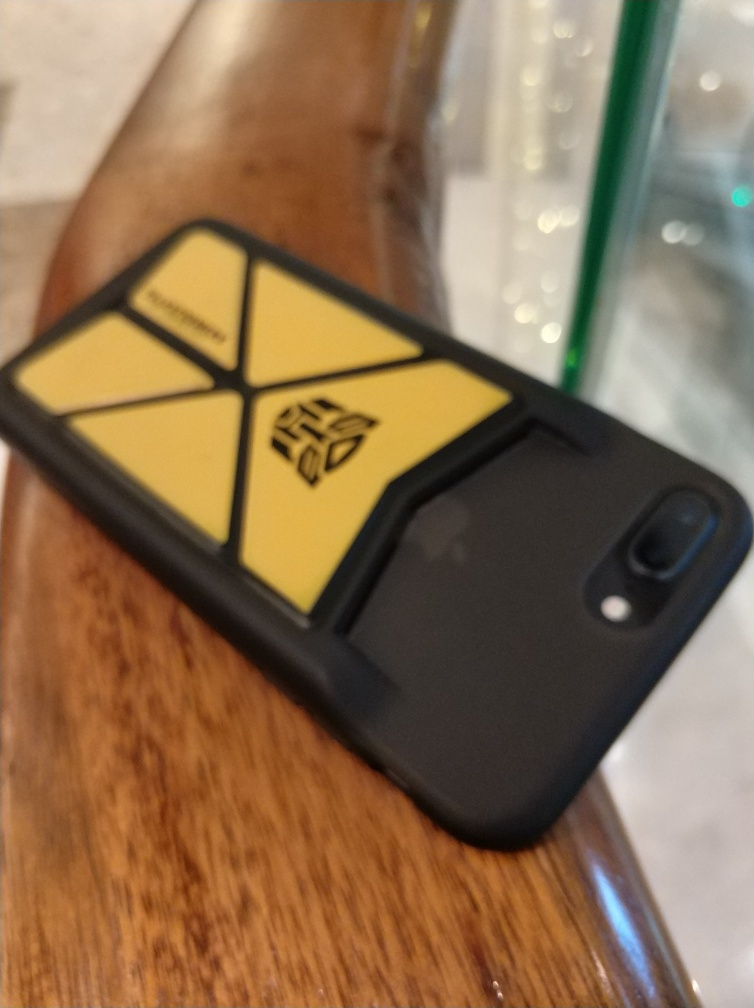Can you describe the style and possible material of the phone case? The phone case is sleek and modern, featuring a two-toned design: predominantly black with a prominent yellow emblem. The case material appears to be a sturdy plastic or rubber, designed to protect the device. Is there anything that indicates the brand of the phone? Although the image is out of focus and the brand logo is not clearly visible, the overall design suggests it could be a contemporary model from a popular smartphone manufacturer. 